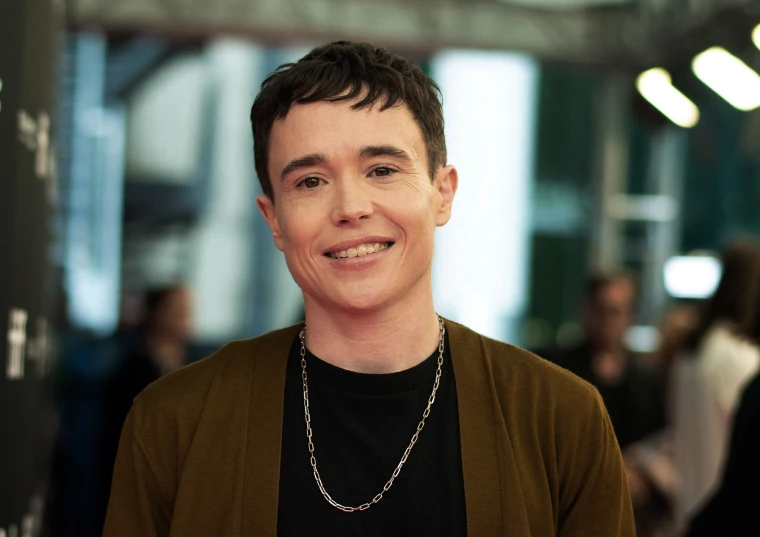Let’s get imaginative. Suppose this snapshot was taken in an alternate universe. Describe the fantastical context of this moment. In an alternate universe, this snapshot captures the moment an interdimensional peacekeeper has just succeeded in negotiating a historic treaty between clashing cosmic realms. The blurred background hints at a swirling vortex of stars and nebulae beyond the fabric of time. The stylish ensemble is an intergalactic uniform bearing emblems of various galactic federations. The joy in this person's expression reflects the relief and hope of ushering in a new era of harmony across the galaxies. 